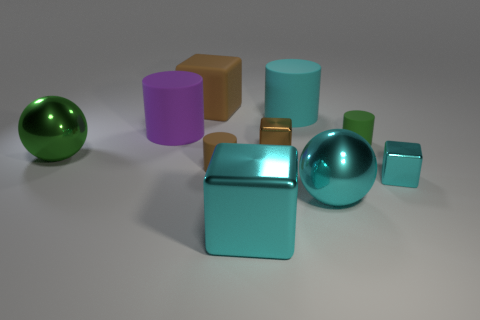Subtract all big cyan metal blocks. How many blocks are left? 3 Subtract all cyan spheres. How many spheres are left? 1 Subtract all balls. How many objects are left? 8 Subtract 3 blocks. How many blocks are left? 1 Subtract all yellow spheres. Subtract all red cylinders. How many spheres are left? 2 Subtract all cyan spheres. How many purple cubes are left? 0 Subtract all green rubber cylinders. Subtract all green metal spheres. How many objects are left? 8 Add 5 big brown things. How many big brown things are left? 6 Add 3 big spheres. How many big spheres exist? 5 Subtract 0 red cubes. How many objects are left? 10 